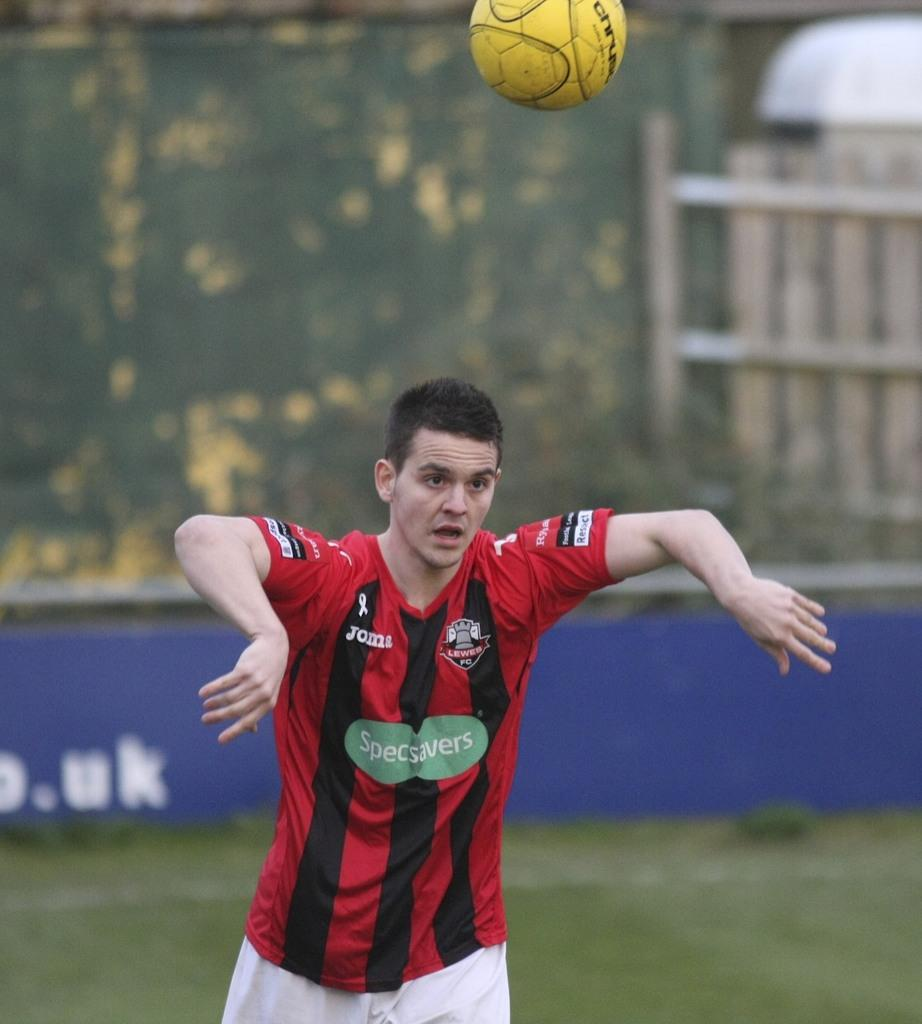Provide a one-sentence caption for the provided image. A soccer player with the brand specsavers advertised on his jersey. 